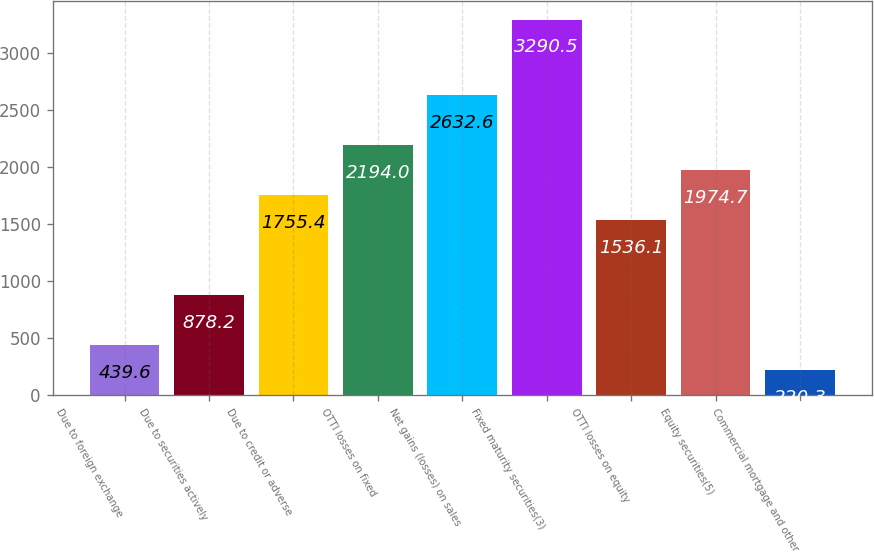Convert chart. <chart><loc_0><loc_0><loc_500><loc_500><bar_chart><fcel>Due to foreign exchange<fcel>Due to securities actively<fcel>Due to credit or adverse<fcel>OTTI losses on fixed<fcel>Net gains (losses) on sales<fcel>Fixed maturity securities(3)<fcel>OTTI losses on equity<fcel>Equity securities(5)<fcel>Commercial mortgage and other<nl><fcel>439.6<fcel>878.2<fcel>1755.4<fcel>2194<fcel>2632.6<fcel>3290.5<fcel>1536.1<fcel>1974.7<fcel>220.3<nl></chart> 